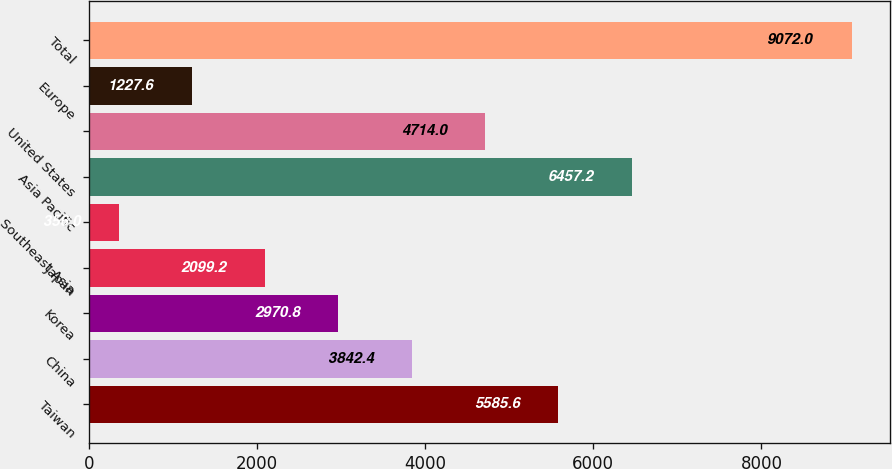Convert chart to OTSL. <chart><loc_0><loc_0><loc_500><loc_500><bar_chart><fcel>Taiwan<fcel>China<fcel>Korea<fcel>Japan<fcel>Southeast Asia<fcel>Asia Pacific<fcel>United States<fcel>Europe<fcel>Total<nl><fcel>5585.6<fcel>3842.4<fcel>2970.8<fcel>2099.2<fcel>356<fcel>6457.2<fcel>4714<fcel>1227.6<fcel>9072<nl></chart> 